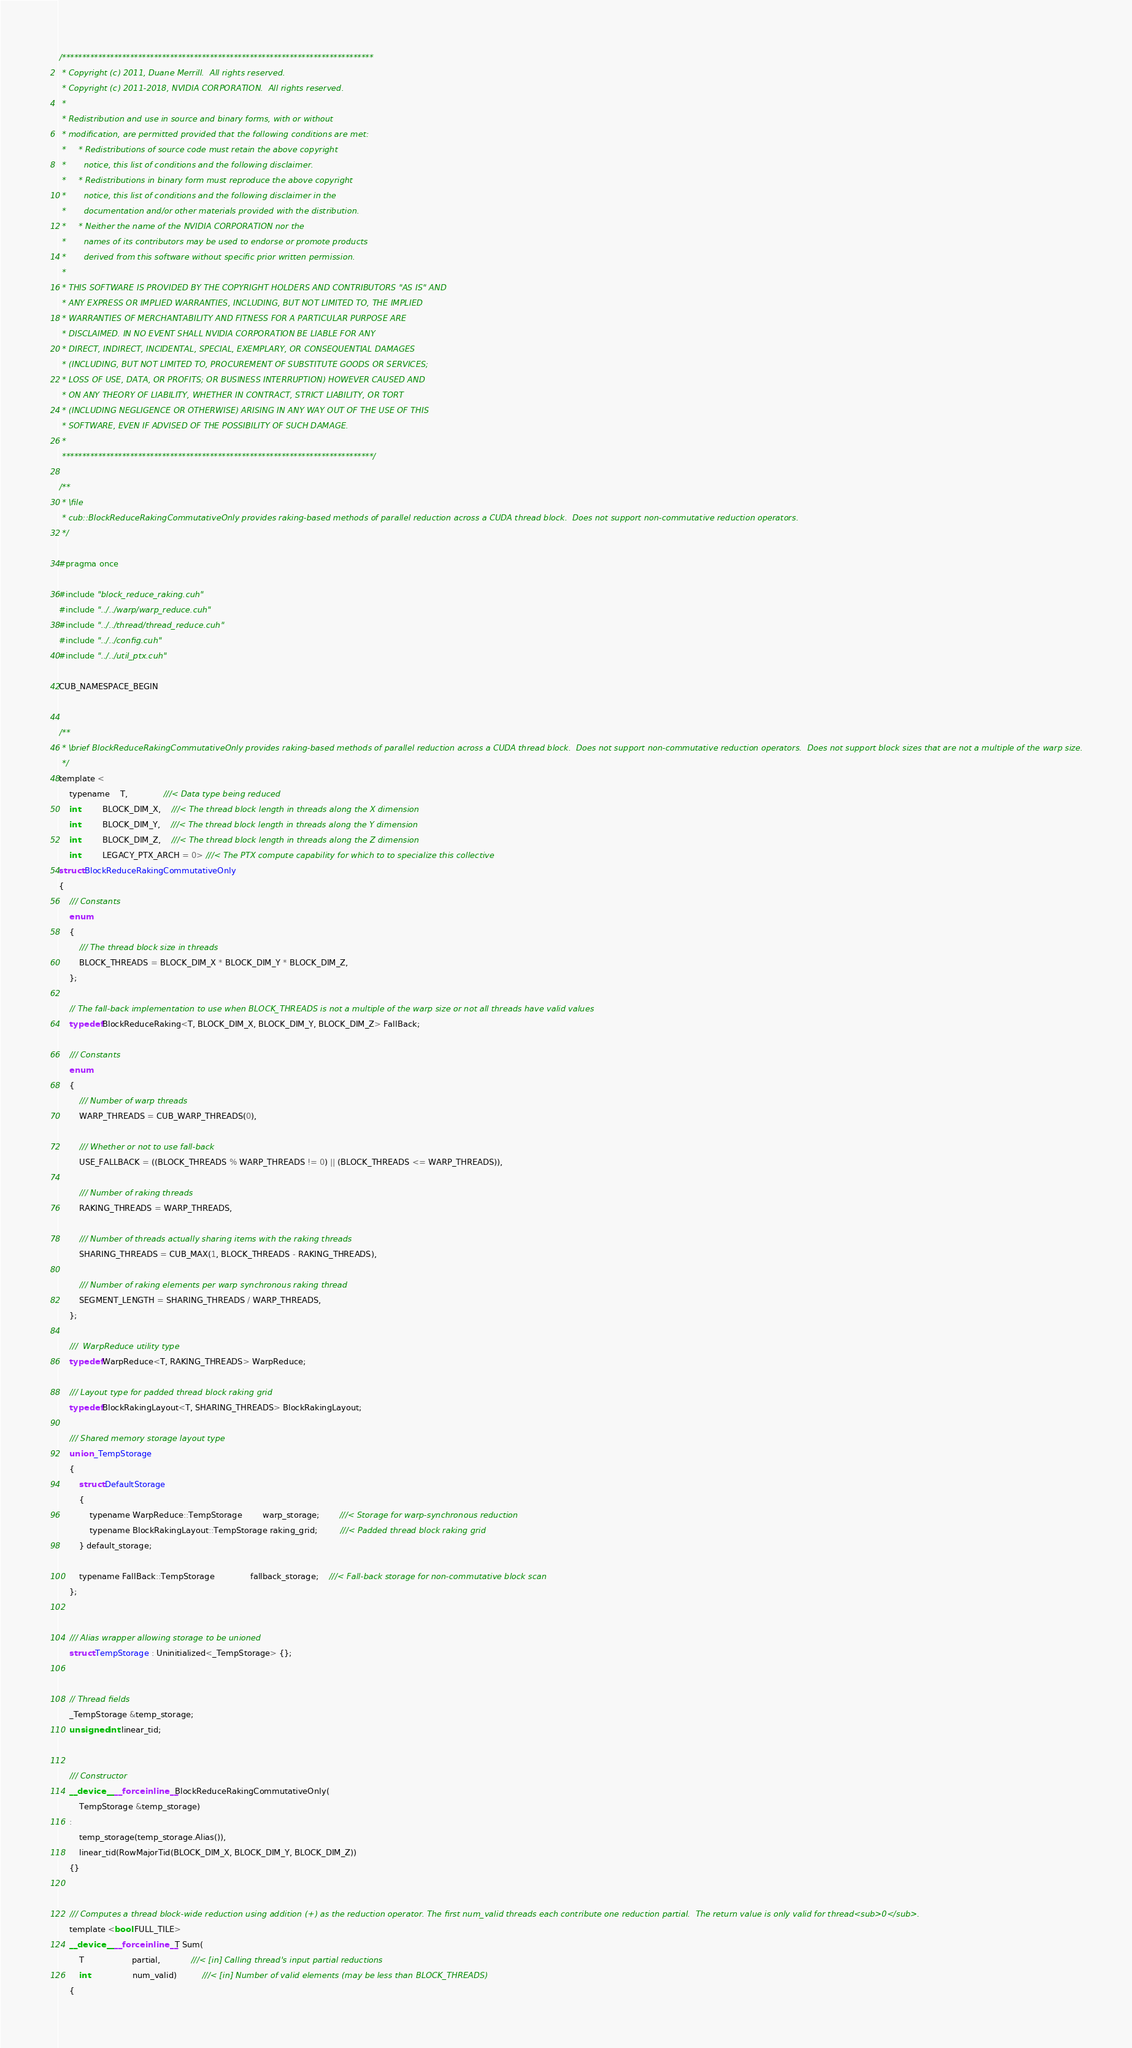<code> <loc_0><loc_0><loc_500><loc_500><_Cuda_>/******************************************************************************
 * Copyright (c) 2011, Duane Merrill.  All rights reserved.
 * Copyright (c) 2011-2018, NVIDIA CORPORATION.  All rights reserved.
 * 
 * Redistribution and use in source and binary forms, with or without
 * modification, are permitted provided that the following conditions are met:
 *     * Redistributions of source code must retain the above copyright
 *       notice, this list of conditions and the following disclaimer.
 *     * Redistributions in binary form must reproduce the above copyright
 *       notice, this list of conditions and the following disclaimer in the
 *       documentation and/or other materials provided with the distribution.
 *     * Neither the name of the NVIDIA CORPORATION nor the
 *       names of its contributors may be used to endorse or promote products
 *       derived from this software without specific prior written permission.
 * 
 * THIS SOFTWARE IS PROVIDED BY THE COPYRIGHT HOLDERS AND CONTRIBUTORS "AS IS" AND
 * ANY EXPRESS OR IMPLIED WARRANTIES, INCLUDING, BUT NOT LIMITED TO, THE IMPLIED
 * WARRANTIES OF MERCHANTABILITY AND FITNESS FOR A PARTICULAR PURPOSE ARE
 * DISCLAIMED. IN NO EVENT SHALL NVIDIA CORPORATION BE LIABLE FOR ANY
 * DIRECT, INDIRECT, INCIDENTAL, SPECIAL, EXEMPLARY, OR CONSEQUENTIAL DAMAGES
 * (INCLUDING, BUT NOT LIMITED TO, PROCUREMENT OF SUBSTITUTE GOODS OR SERVICES;
 * LOSS OF USE, DATA, OR PROFITS; OR BUSINESS INTERRUPTION) HOWEVER CAUSED AND
 * ON ANY THEORY OF LIABILITY, WHETHER IN CONTRACT, STRICT LIABILITY, OR TORT
 * (INCLUDING NEGLIGENCE OR OTHERWISE) ARISING IN ANY WAY OUT OF THE USE OF THIS
 * SOFTWARE, EVEN IF ADVISED OF THE POSSIBILITY OF SUCH DAMAGE.
 *
 ******************************************************************************/

/**
 * \file
 * cub::BlockReduceRakingCommutativeOnly provides raking-based methods of parallel reduction across a CUDA thread block.  Does not support non-commutative reduction operators.
 */

#pragma once

#include "block_reduce_raking.cuh"
#include "../../warp/warp_reduce.cuh"
#include "../../thread/thread_reduce.cuh"
#include "../../config.cuh"
#include "../../util_ptx.cuh"

CUB_NAMESPACE_BEGIN


/**
 * \brief BlockReduceRakingCommutativeOnly provides raking-based methods of parallel reduction across a CUDA thread block.  Does not support non-commutative reduction operators.  Does not support block sizes that are not a multiple of the warp size.
 */
template <
    typename    T,              ///< Data type being reduced
    int         BLOCK_DIM_X,    ///< The thread block length in threads along the X dimension
    int         BLOCK_DIM_Y,    ///< The thread block length in threads along the Y dimension
    int         BLOCK_DIM_Z,    ///< The thread block length in threads along the Z dimension
    int         LEGACY_PTX_ARCH = 0> ///< The PTX compute capability for which to to specialize this collective
struct BlockReduceRakingCommutativeOnly
{
    /// Constants
    enum
    {
        /// The thread block size in threads
        BLOCK_THREADS = BLOCK_DIM_X * BLOCK_DIM_Y * BLOCK_DIM_Z,
    };

    // The fall-back implementation to use when BLOCK_THREADS is not a multiple of the warp size or not all threads have valid values
    typedef BlockReduceRaking<T, BLOCK_DIM_X, BLOCK_DIM_Y, BLOCK_DIM_Z> FallBack;

    /// Constants
    enum
    {
        /// Number of warp threads
        WARP_THREADS = CUB_WARP_THREADS(0),

        /// Whether or not to use fall-back
        USE_FALLBACK = ((BLOCK_THREADS % WARP_THREADS != 0) || (BLOCK_THREADS <= WARP_THREADS)),

        /// Number of raking threads
        RAKING_THREADS = WARP_THREADS,

        /// Number of threads actually sharing items with the raking threads
        SHARING_THREADS = CUB_MAX(1, BLOCK_THREADS - RAKING_THREADS),

        /// Number of raking elements per warp synchronous raking thread
        SEGMENT_LENGTH = SHARING_THREADS / WARP_THREADS,
    };

    ///  WarpReduce utility type
    typedef WarpReduce<T, RAKING_THREADS> WarpReduce;

    /// Layout type for padded thread block raking grid
    typedef BlockRakingLayout<T, SHARING_THREADS> BlockRakingLayout;

    /// Shared memory storage layout type
    union _TempStorage
    {
        struct DefaultStorage
        {
            typename WarpReduce::TempStorage        warp_storage;        ///< Storage for warp-synchronous reduction
            typename BlockRakingLayout::TempStorage raking_grid;         ///< Padded thread block raking grid
        } default_storage;

        typename FallBack::TempStorage              fallback_storage;    ///< Fall-back storage for non-commutative block scan
    };


    /// Alias wrapper allowing storage to be unioned
    struct TempStorage : Uninitialized<_TempStorage> {};


    // Thread fields
    _TempStorage &temp_storage;
    unsigned int linear_tid;


    /// Constructor
    __device__ __forceinline__ BlockReduceRakingCommutativeOnly(
        TempStorage &temp_storage)
    :
        temp_storage(temp_storage.Alias()),
        linear_tid(RowMajorTid(BLOCK_DIM_X, BLOCK_DIM_Y, BLOCK_DIM_Z))
    {}


    /// Computes a thread block-wide reduction using addition (+) as the reduction operator. The first num_valid threads each contribute one reduction partial.  The return value is only valid for thread<sub>0</sub>.
    template <bool FULL_TILE>
    __device__ __forceinline__ T Sum(
        T                   partial,            ///< [in] Calling thread's input partial reductions
        int                 num_valid)          ///< [in] Number of valid elements (may be less than BLOCK_THREADS)
    {</code> 